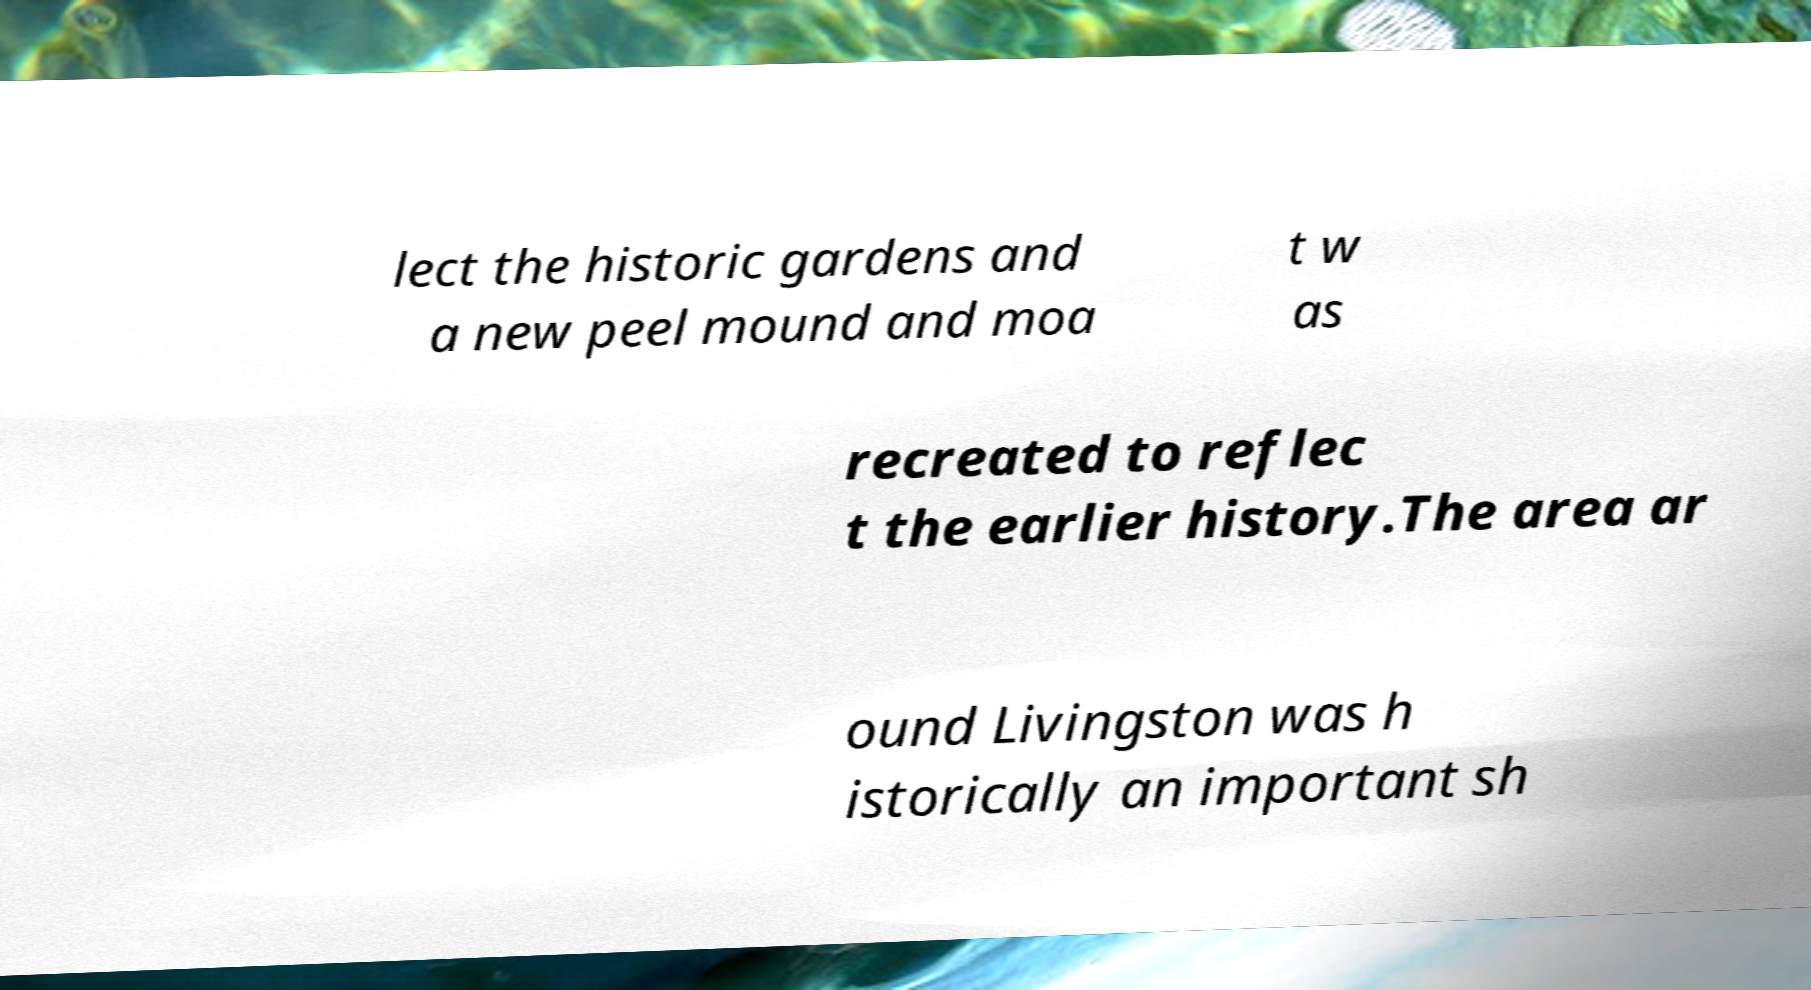Can you read and provide the text displayed in the image?This photo seems to have some interesting text. Can you extract and type it out for me? lect the historic gardens and a new peel mound and moa t w as recreated to reflec t the earlier history.The area ar ound Livingston was h istorically an important sh 